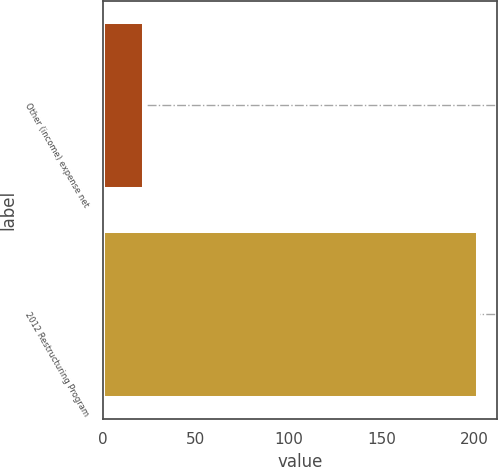Convert chart. <chart><loc_0><loc_0><loc_500><loc_500><bar_chart><fcel>Other (income) expense net<fcel>2012 Restructuring Program<nl><fcel>22<fcel>202<nl></chart> 